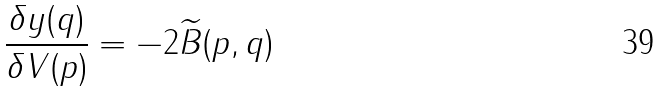Convert formula to latex. <formula><loc_0><loc_0><loc_500><loc_500>\frac { \delta y ( q ) } { \delta V ( p ) } = - 2 \widetilde { B } ( p , q )</formula> 